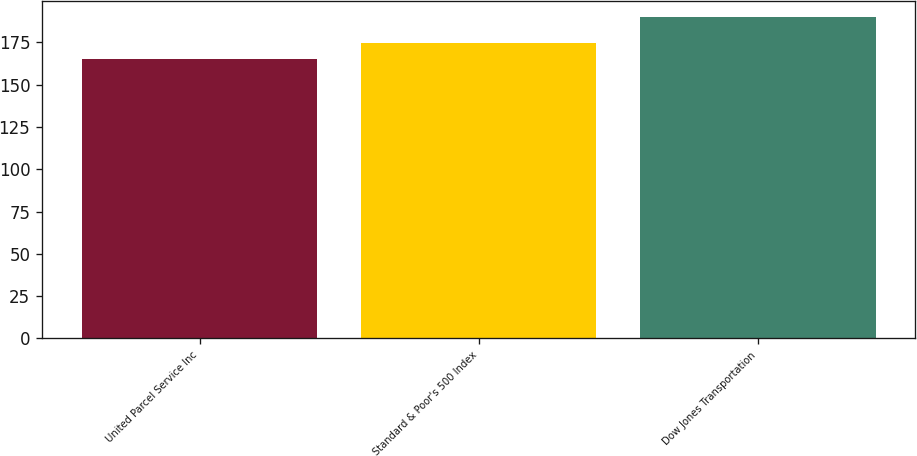Convert chart. <chart><loc_0><loc_0><loc_500><loc_500><bar_chart><fcel>United Parcel Service Inc<fcel>Standard & Poor's 500 Index<fcel>Dow Jones Transportation<nl><fcel>165.35<fcel>174.54<fcel>190.07<nl></chart> 